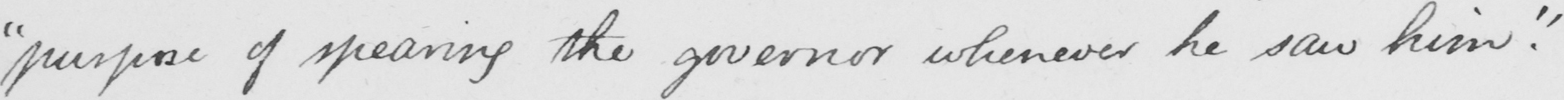Can you read and transcribe this handwriting? " purpose of spearing the governor whenever he saw him . "   _ 